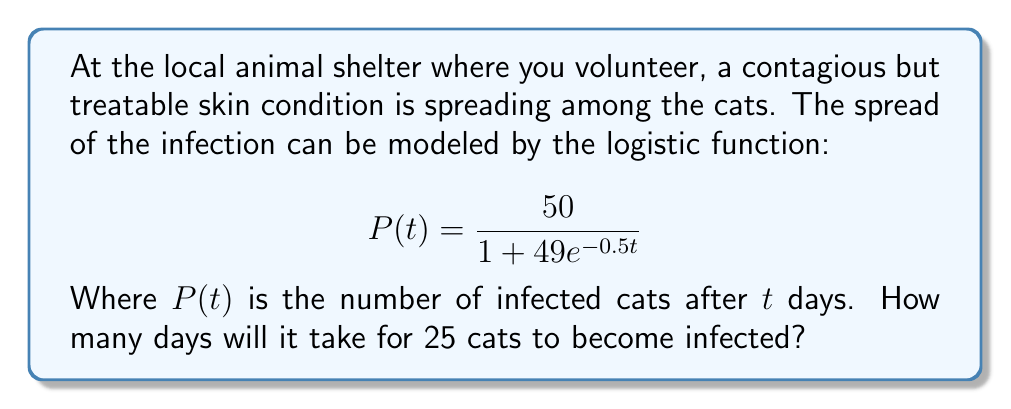Could you help me with this problem? Let's approach this step-by-step:

1) We want to find $t$ when $P(t) = 25$. So, we set up the equation:

   $$25 = \frac{50}{1 + 49e^{-0.5t}}$$

2) Multiply both sides by $(1 + 49e^{-0.5t})$:

   $$25(1 + 49e^{-0.5t}) = 50$$

3) Distribute on the left side:

   $$25 + 1225e^{-0.5t} = 50$$

4) Subtract 25 from both sides:

   $$1225e^{-0.5t} = 25$$

5) Divide both sides by 1225:

   $$e^{-0.5t} = \frac{1}{49}$$

6) Take the natural log of both sides:

   $$-0.5t = \ln(\frac{1}{49})$$

7) Multiply both sides by -2:

   $$t = -2\ln(\frac{1}{49})$$

8) Simplify:

   $$t = 2\ln(49)$$

9) Calculate the value (you can use a calculator):

   $$t \approx 7.82$$

Therefore, it will take approximately 7.82 days for 25 cats to become infected.
Answer: $2\ln(49) \approx 7.82$ days 